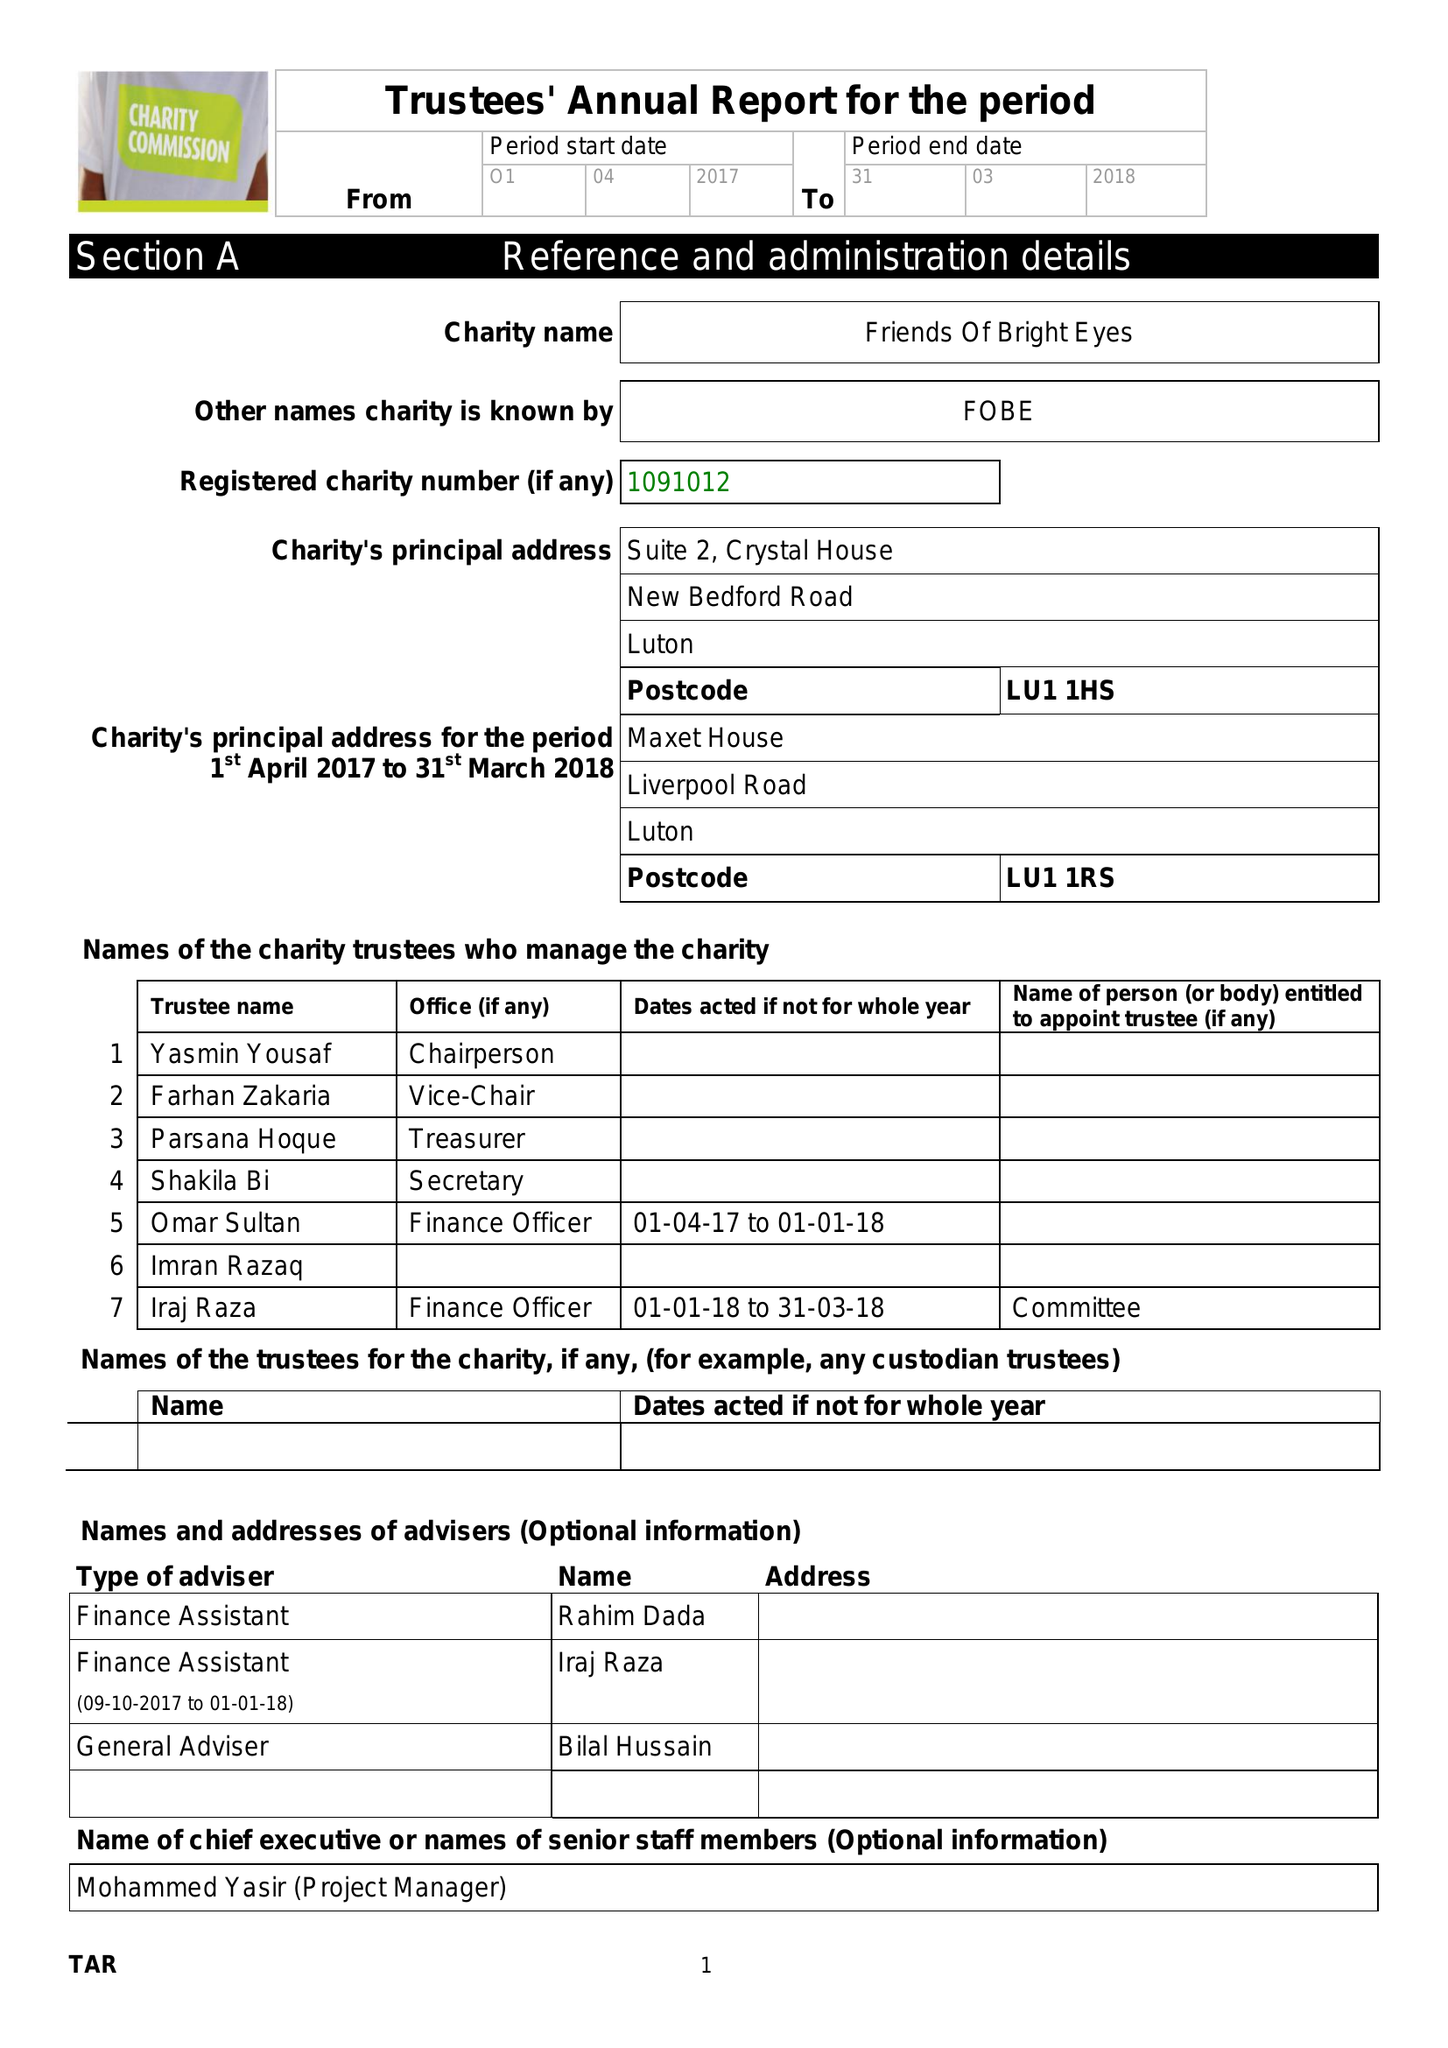What is the value for the income_annually_in_british_pounds?
Answer the question using a single word or phrase. 117836.00 